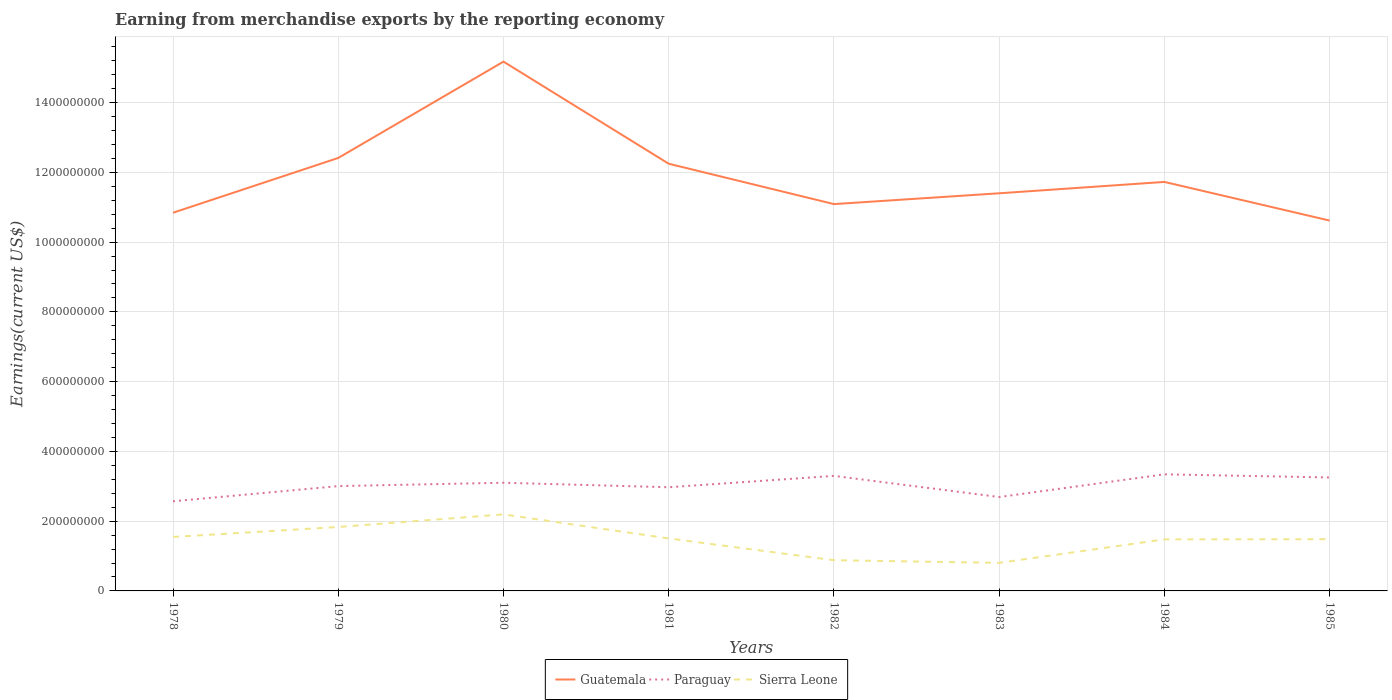How many different coloured lines are there?
Make the answer very short. 3. Across all years, what is the maximum amount earned from merchandise exports in Paraguay?
Provide a short and direct response. 2.57e+08. In which year was the amount earned from merchandise exports in Paraguay maximum?
Provide a succinct answer. 1978. What is the total amount earned from merchandise exports in Guatemala in the graph?
Give a very brief answer. -3.10e+07. What is the difference between the highest and the second highest amount earned from merchandise exports in Sierra Leone?
Your response must be concise. 1.39e+08. What is the difference between the highest and the lowest amount earned from merchandise exports in Paraguay?
Your response must be concise. 4. Is the amount earned from merchandise exports in Guatemala strictly greater than the amount earned from merchandise exports in Sierra Leone over the years?
Your answer should be very brief. No. What is the difference between two consecutive major ticks on the Y-axis?
Give a very brief answer. 2.00e+08. Are the values on the major ticks of Y-axis written in scientific E-notation?
Offer a very short reply. No. Does the graph contain any zero values?
Your answer should be compact. No. Does the graph contain grids?
Offer a terse response. Yes. Where does the legend appear in the graph?
Your answer should be very brief. Bottom center. How many legend labels are there?
Make the answer very short. 3. How are the legend labels stacked?
Your answer should be very brief. Horizontal. What is the title of the graph?
Your answer should be compact. Earning from merchandise exports by the reporting economy. Does "United Kingdom" appear as one of the legend labels in the graph?
Your answer should be compact. No. What is the label or title of the Y-axis?
Your answer should be compact. Earnings(current US$). What is the Earnings(current US$) in Guatemala in 1978?
Provide a succinct answer. 1.08e+09. What is the Earnings(current US$) of Paraguay in 1978?
Offer a terse response. 2.57e+08. What is the Earnings(current US$) in Sierra Leone in 1978?
Make the answer very short. 1.55e+08. What is the Earnings(current US$) of Guatemala in 1979?
Provide a succinct answer. 1.24e+09. What is the Earnings(current US$) in Paraguay in 1979?
Keep it short and to the point. 3.00e+08. What is the Earnings(current US$) in Sierra Leone in 1979?
Offer a terse response. 1.83e+08. What is the Earnings(current US$) in Guatemala in 1980?
Give a very brief answer. 1.52e+09. What is the Earnings(current US$) in Paraguay in 1980?
Offer a terse response. 3.10e+08. What is the Earnings(current US$) in Sierra Leone in 1980?
Your answer should be very brief. 2.19e+08. What is the Earnings(current US$) in Guatemala in 1981?
Give a very brief answer. 1.22e+09. What is the Earnings(current US$) of Paraguay in 1981?
Give a very brief answer. 2.97e+08. What is the Earnings(current US$) in Sierra Leone in 1981?
Offer a terse response. 1.50e+08. What is the Earnings(current US$) of Guatemala in 1982?
Offer a very short reply. 1.11e+09. What is the Earnings(current US$) in Paraguay in 1982?
Ensure brevity in your answer.  3.30e+08. What is the Earnings(current US$) of Sierra Leone in 1982?
Offer a very short reply. 8.81e+07. What is the Earnings(current US$) of Guatemala in 1983?
Ensure brevity in your answer.  1.14e+09. What is the Earnings(current US$) in Paraguay in 1983?
Provide a short and direct response. 2.69e+08. What is the Earnings(current US$) of Sierra Leone in 1983?
Your answer should be very brief. 8.05e+07. What is the Earnings(current US$) in Guatemala in 1984?
Make the answer very short. 1.17e+09. What is the Earnings(current US$) in Paraguay in 1984?
Provide a succinct answer. 3.34e+08. What is the Earnings(current US$) of Sierra Leone in 1984?
Your response must be concise. 1.48e+08. What is the Earnings(current US$) in Guatemala in 1985?
Provide a short and direct response. 1.06e+09. What is the Earnings(current US$) in Paraguay in 1985?
Provide a succinct answer. 3.25e+08. What is the Earnings(current US$) of Sierra Leone in 1985?
Provide a succinct answer. 1.48e+08. Across all years, what is the maximum Earnings(current US$) of Guatemala?
Ensure brevity in your answer.  1.52e+09. Across all years, what is the maximum Earnings(current US$) of Paraguay?
Offer a terse response. 3.34e+08. Across all years, what is the maximum Earnings(current US$) in Sierra Leone?
Make the answer very short. 2.19e+08. Across all years, what is the minimum Earnings(current US$) of Guatemala?
Give a very brief answer. 1.06e+09. Across all years, what is the minimum Earnings(current US$) in Paraguay?
Your response must be concise. 2.57e+08. Across all years, what is the minimum Earnings(current US$) in Sierra Leone?
Give a very brief answer. 8.05e+07. What is the total Earnings(current US$) of Guatemala in the graph?
Keep it short and to the point. 9.55e+09. What is the total Earnings(current US$) of Paraguay in the graph?
Ensure brevity in your answer.  2.42e+09. What is the total Earnings(current US$) in Sierra Leone in the graph?
Keep it short and to the point. 1.17e+09. What is the difference between the Earnings(current US$) of Guatemala in 1978 and that in 1979?
Give a very brief answer. -1.57e+08. What is the difference between the Earnings(current US$) in Paraguay in 1978 and that in 1979?
Keep it short and to the point. -4.35e+07. What is the difference between the Earnings(current US$) in Sierra Leone in 1978 and that in 1979?
Ensure brevity in your answer.  -2.86e+07. What is the difference between the Earnings(current US$) of Guatemala in 1978 and that in 1980?
Offer a terse response. -4.33e+08. What is the difference between the Earnings(current US$) of Paraguay in 1978 and that in 1980?
Give a very brief answer. -5.31e+07. What is the difference between the Earnings(current US$) in Sierra Leone in 1978 and that in 1980?
Provide a short and direct response. -6.47e+07. What is the difference between the Earnings(current US$) in Guatemala in 1978 and that in 1981?
Your answer should be very brief. -1.40e+08. What is the difference between the Earnings(current US$) of Paraguay in 1978 and that in 1981?
Keep it short and to the point. -4.02e+07. What is the difference between the Earnings(current US$) of Sierra Leone in 1978 and that in 1981?
Provide a short and direct response. 4.26e+06. What is the difference between the Earnings(current US$) in Guatemala in 1978 and that in 1982?
Offer a very short reply. -2.48e+07. What is the difference between the Earnings(current US$) of Paraguay in 1978 and that in 1982?
Make the answer very short. -7.28e+07. What is the difference between the Earnings(current US$) of Sierra Leone in 1978 and that in 1982?
Keep it short and to the point. 6.67e+07. What is the difference between the Earnings(current US$) of Guatemala in 1978 and that in 1983?
Provide a succinct answer. -5.58e+07. What is the difference between the Earnings(current US$) in Paraguay in 1978 and that in 1983?
Offer a terse response. -1.22e+07. What is the difference between the Earnings(current US$) in Sierra Leone in 1978 and that in 1983?
Provide a succinct answer. 7.43e+07. What is the difference between the Earnings(current US$) in Guatemala in 1978 and that in 1984?
Provide a succinct answer. -8.84e+07. What is the difference between the Earnings(current US$) of Paraguay in 1978 and that in 1984?
Ensure brevity in your answer.  -7.72e+07. What is the difference between the Earnings(current US$) in Sierra Leone in 1978 and that in 1984?
Make the answer very short. 6.94e+06. What is the difference between the Earnings(current US$) of Guatemala in 1978 and that in 1985?
Offer a terse response. 2.25e+07. What is the difference between the Earnings(current US$) in Paraguay in 1978 and that in 1985?
Your answer should be compact. -6.82e+07. What is the difference between the Earnings(current US$) of Sierra Leone in 1978 and that in 1985?
Your answer should be compact. 6.46e+06. What is the difference between the Earnings(current US$) in Guatemala in 1979 and that in 1980?
Ensure brevity in your answer.  -2.76e+08. What is the difference between the Earnings(current US$) of Paraguay in 1979 and that in 1980?
Offer a very short reply. -9.67e+06. What is the difference between the Earnings(current US$) of Sierra Leone in 1979 and that in 1980?
Offer a terse response. -3.61e+07. What is the difference between the Earnings(current US$) in Guatemala in 1979 and that in 1981?
Provide a succinct answer. 1.66e+07. What is the difference between the Earnings(current US$) of Paraguay in 1979 and that in 1981?
Keep it short and to the point. 3.25e+06. What is the difference between the Earnings(current US$) of Sierra Leone in 1979 and that in 1981?
Provide a succinct answer. 3.28e+07. What is the difference between the Earnings(current US$) of Guatemala in 1979 and that in 1982?
Your answer should be compact. 1.32e+08. What is the difference between the Earnings(current US$) of Paraguay in 1979 and that in 1982?
Offer a terse response. -2.93e+07. What is the difference between the Earnings(current US$) in Sierra Leone in 1979 and that in 1982?
Your answer should be very brief. 9.53e+07. What is the difference between the Earnings(current US$) in Guatemala in 1979 and that in 1983?
Offer a very short reply. 1.01e+08. What is the difference between the Earnings(current US$) of Paraguay in 1979 and that in 1983?
Provide a succinct answer. 3.13e+07. What is the difference between the Earnings(current US$) of Sierra Leone in 1979 and that in 1983?
Provide a succinct answer. 1.03e+08. What is the difference between the Earnings(current US$) of Guatemala in 1979 and that in 1984?
Offer a terse response. 6.87e+07. What is the difference between the Earnings(current US$) of Paraguay in 1979 and that in 1984?
Ensure brevity in your answer.  -3.38e+07. What is the difference between the Earnings(current US$) of Sierra Leone in 1979 and that in 1984?
Keep it short and to the point. 3.55e+07. What is the difference between the Earnings(current US$) of Guatemala in 1979 and that in 1985?
Offer a terse response. 1.80e+08. What is the difference between the Earnings(current US$) in Paraguay in 1979 and that in 1985?
Provide a short and direct response. -2.48e+07. What is the difference between the Earnings(current US$) of Sierra Leone in 1979 and that in 1985?
Keep it short and to the point. 3.50e+07. What is the difference between the Earnings(current US$) of Guatemala in 1980 and that in 1981?
Provide a short and direct response. 2.93e+08. What is the difference between the Earnings(current US$) of Paraguay in 1980 and that in 1981?
Make the answer very short. 1.29e+07. What is the difference between the Earnings(current US$) in Sierra Leone in 1980 and that in 1981?
Your answer should be very brief. 6.90e+07. What is the difference between the Earnings(current US$) in Guatemala in 1980 and that in 1982?
Give a very brief answer. 4.08e+08. What is the difference between the Earnings(current US$) in Paraguay in 1980 and that in 1982?
Provide a short and direct response. -1.97e+07. What is the difference between the Earnings(current US$) of Sierra Leone in 1980 and that in 1982?
Your response must be concise. 1.31e+08. What is the difference between the Earnings(current US$) in Guatemala in 1980 and that in 1983?
Give a very brief answer. 3.77e+08. What is the difference between the Earnings(current US$) in Paraguay in 1980 and that in 1983?
Ensure brevity in your answer.  4.10e+07. What is the difference between the Earnings(current US$) of Sierra Leone in 1980 and that in 1983?
Your response must be concise. 1.39e+08. What is the difference between the Earnings(current US$) of Guatemala in 1980 and that in 1984?
Make the answer very short. 3.45e+08. What is the difference between the Earnings(current US$) in Paraguay in 1980 and that in 1984?
Provide a succinct answer. -2.41e+07. What is the difference between the Earnings(current US$) of Sierra Leone in 1980 and that in 1984?
Keep it short and to the point. 7.17e+07. What is the difference between the Earnings(current US$) in Guatemala in 1980 and that in 1985?
Your response must be concise. 4.56e+08. What is the difference between the Earnings(current US$) in Paraguay in 1980 and that in 1985?
Ensure brevity in your answer.  -1.51e+07. What is the difference between the Earnings(current US$) of Sierra Leone in 1980 and that in 1985?
Keep it short and to the point. 7.12e+07. What is the difference between the Earnings(current US$) of Guatemala in 1981 and that in 1982?
Offer a terse response. 1.16e+08. What is the difference between the Earnings(current US$) in Paraguay in 1981 and that in 1982?
Provide a short and direct response. -3.26e+07. What is the difference between the Earnings(current US$) of Sierra Leone in 1981 and that in 1982?
Provide a short and direct response. 6.24e+07. What is the difference between the Earnings(current US$) of Guatemala in 1981 and that in 1983?
Give a very brief answer. 8.47e+07. What is the difference between the Earnings(current US$) of Paraguay in 1981 and that in 1983?
Your response must be concise. 2.80e+07. What is the difference between the Earnings(current US$) in Sierra Leone in 1981 and that in 1983?
Your response must be concise. 7.00e+07. What is the difference between the Earnings(current US$) of Guatemala in 1981 and that in 1984?
Your answer should be compact. 5.21e+07. What is the difference between the Earnings(current US$) in Paraguay in 1981 and that in 1984?
Offer a terse response. -3.70e+07. What is the difference between the Earnings(current US$) of Sierra Leone in 1981 and that in 1984?
Provide a succinct answer. 2.68e+06. What is the difference between the Earnings(current US$) in Guatemala in 1981 and that in 1985?
Provide a short and direct response. 1.63e+08. What is the difference between the Earnings(current US$) of Paraguay in 1981 and that in 1985?
Your response must be concise. -2.80e+07. What is the difference between the Earnings(current US$) in Sierra Leone in 1981 and that in 1985?
Make the answer very short. 2.20e+06. What is the difference between the Earnings(current US$) of Guatemala in 1982 and that in 1983?
Your answer should be very brief. -3.10e+07. What is the difference between the Earnings(current US$) of Paraguay in 1982 and that in 1983?
Offer a very short reply. 6.06e+07. What is the difference between the Earnings(current US$) in Sierra Leone in 1982 and that in 1983?
Your answer should be compact. 7.59e+06. What is the difference between the Earnings(current US$) of Guatemala in 1982 and that in 1984?
Provide a short and direct response. -6.36e+07. What is the difference between the Earnings(current US$) in Paraguay in 1982 and that in 1984?
Provide a succinct answer. -4.46e+06. What is the difference between the Earnings(current US$) in Sierra Leone in 1982 and that in 1984?
Your response must be concise. -5.97e+07. What is the difference between the Earnings(current US$) of Guatemala in 1982 and that in 1985?
Keep it short and to the point. 4.73e+07. What is the difference between the Earnings(current US$) of Paraguay in 1982 and that in 1985?
Ensure brevity in your answer.  4.56e+06. What is the difference between the Earnings(current US$) of Sierra Leone in 1982 and that in 1985?
Make the answer very short. -6.02e+07. What is the difference between the Earnings(current US$) of Guatemala in 1983 and that in 1984?
Your answer should be compact. -3.26e+07. What is the difference between the Earnings(current US$) in Paraguay in 1983 and that in 1984?
Offer a terse response. -6.51e+07. What is the difference between the Earnings(current US$) in Sierra Leone in 1983 and that in 1984?
Give a very brief answer. -6.73e+07. What is the difference between the Earnings(current US$) in Guatemala in 1983 and that in 1985?
Your response must be concise. 7.83e+07. What is the difference between the Earnings(current US$) of Paraguay in 1983 and that in 1985?
Your answer should be very brief. -5.61e+07. What is the difference between the Earnings(current US$) of Sierra Leone in 1983 and that in 1985?
Keep it short and to the point. -6.78e+07. What is the difference between the Earnings(current US$) in Guatemala in 1984 and that in 1985?
Keep it short and to the point. 1.11e+08. What is the difference between the Earnings(current US$) of Paraguay in 1984 and that in 1985?
Your answer should be compact. 9.01e+06. What is the difference between the Earnings(current US$) of Sierra Leone in 1984 and that in 1985?
Your answer should be very brief. -4.81e+05. What is the difference between the Earnings(current US$) of Guatemala in 1978 and the Earnings(current US$) of Paraguay in 1979?
Your response must be concise. 7.84e+08. What is the difference between the Earnings(current US$) in Guatemala in 1978 and the Earnings(current US$) in Sierra Leone in 1979?
Your response must be concise. 9.01e+08. What is the difference between the Earnings(current US$) in Paraguay in 1978 and the Earnings(current US$) in Sierra Leone in 1979?
Make the answer very short. 7.37e+07. What is the difference between the Earnings(current US$) of Guatemala in 1978 and the Earnings(current US$) of Paraguay in 1980?
Keep it short and to the point. 7.74e+08. What is the difference between the Earnings(current US$) of Guatemala in 1978 and the Earnings(current US$) of Sierra Leone in 1980?
Provide a short and direct response. 8.65e+08. What is the difference between the Earnings(current US$) of Paraguay in 1978 and the Earnings(current US$) of Sierra Leone in 1980?
Provide a succinct answer. 3.76e+07. What is the difference between the Earnings(current US$) in Guatemala in 1978 and the Earnings(current US$) in Paraguay in 1981?
Offer a very short reply. 7.87e+08. What is the difference between the Earnings(current US$) of Guatemala in 1978 and the Earnings(current US$) of Sierra Leone in 1981?
Ensure brevity in your answer.  9.34e+08. What is the difference between the Earnings(current US$) in Paraguay in 1978 and the Earnings(current US$) in Sierra Leone in 1981?
Provide a short and direct response. 1.07e+08. What is the difference between the Earnings(current US$) of Guatemala in 1978 and the Earnings(current US$) of Paraguay in 1982?
Your answer should be compact. 7.54e+08. What is the difference between the Earnings(current US$) in Guatemala in 1978 and the Earnings(current US$) in Sierra Leone in 1982?
Keep it short and to the point. 9.96e+08. What is the difference between the Earnings(current US$) of Paraguay in 1978 and the Earnings(current US$) of Sierra Leone in 1982?
Give a very brief answer. 1.69e+08. What is the difference between the Earnings(current US$) of Guatemala in 1978 and the Earnings(current US$) of Paraguay in 1983?
Provide a succinct answer. 8.15e+08. What is the difference between the Earnings(current US$) of Guatemala in 1978 and the Earnings(current US$) of Sierra Leone in 1983?
Provide a short and direct response. 1.00e+09. What is the difference between the Earnings(current US$) of Paraguay in 1978 and the Earnings(current US$) of Sierra Leone in 1983?
Keep it short and to the point. 1.77e+08. What is the difference between the Earnings(current US$) of Guatemala in 1978 and the Earnings(current US$) of Paraguay in 1984?
Provide a succinct answer. 7.50e+08. What is the difference between the Earnings(current US$) in Guatemala in 1978 and the Earnings(current US$) in Sierra Leone in 1984?
Give a very brief answer. 9.36e+08. What is the difference between the Earnings(current US$) in Paraguay in 1978 and the Earnings(current US$) in Sierra Leone in 1984?
Provide a succinct answer. 1.09e+08. What is the difference between the Earnings(current US$) of Guatemala in 1978 and the Earnings(current US$) of Paraguay in 1985?
Your answer should be compact. 7.59e+08. What is the difference between the Earnings(current US$) in Guatemala in 1978 and the Earnings(current US$) in Sierra Leone in 1985?
Offer a very short reply. 9.36e+08. What is the difference between the Earnings(current US$) in Paraguay in 1978 and the Earnings(current US$) in Sierra Leone in 1985?
Your answer should be very brief. 1.09e+08. What is the difference between the Earnings(current US$) of Guatemala in 1979 and the Earnings(current US$) of Paraguay in 1980?
Keep it short and to the point. 9.31e+08. What is the difference between the Earnings(current US$) in Guatemala in 1979 and the Earnings(current US$) in Sierra Leone in 1980?
Make the answer very short. 1.02e+09. What is the difference between the Earnings(current US$) of Paraguay in 1979 and the Earnings(current US$) of Sierra Leone in 1980?
Your answer should be compact. 8.10e+07. What is the difference between the Earnings(current US$) of Guatemala in 1979 and the Earnings(current US$) of Paraguay in 1981?
Offer a very short reply. 9.44e+08. What is the difference between the Earnings(current US$) of Guatemala in 1979 and the Earnings(current US$) of Sierra Leone in 1981?
Provide a short and direct response. 1.09e+09. What is the difference between the Earnings(current US$) in Paraguay in 1979 and the Earnings(current US$) in Sierra Leone in 1981?
Your answer should be compact. 1.50e+08. What is the difference between the Earnings(current US$) in Guatemala in 1979 and the Earnings(current US$) in Paraguay in 1982?
Offer a very short reply. 9.12e+08. What is the difference between the Earnings(current US$) of Guatemala in 1979 and the Earnings(current US$) of Sierra Leone in 1982?
Your answer should be very brief. 1.15e+09. What is the difference between the Earnings(current US$) of Paraguay in 1979 and the Earnings(current US$) of Sierra Leone in 1982?
Offer a very short reply. 2.12e+08. What is the difference between the Earnings(current US$) in Guatemala in 1979 and the Earnings(current US$) in Paraguay in 1983?
Keep it short and to the point. 9.72e+08. What is the difference between the Earnings(current US$) in Guatemala in 1979 and the Earnings(current US$) in Sierra Leone in 1983?
Keep it short and to the point. 1.16e+09. What is the difference between the Earnings(current US$) in Paraguay in 1979 and the Earnings(current US$) in Sierra Leone in 1983?
Offer a terse response. 2.20e+08. What is the difference between the Earnings(current US$) in Guatemala in 1979 and the Earnings(current US$) in Paraguay in 1984?
Offer a terse response. 9.07e+08. What is the difference between the Earnings(current US$) of Guatemala in 1979 and the Earnings(current US$) of Sierra Leone in 1984?
Offer a very short reply. 1.09e+09. What is the difference between the Earnings(current US$) of Paraguay in 1979 and the Earnings(current US$) of Sierra Leone in 1984?
Give a very brief answer. 1.53e+08. What is the difference between the Earnings(current US$) in Guatemala in 1979 and the Earnings(current US$) in Paraguay in 1985?
Provide a short and direct response. 9.16e+08. What is the difference between the Earnings(current US$) of Guatemala in 1979 and the Earnings(current US$) of Sierra Leone in 1985?
Your response must be concise. 1.09e+09. What is the difference between the Earnings(current US$) in Paraguay in 1979 and the Earnings(current US$) in Sierra Leone in 1985?
Provide a succinct answer. 1.52e+08. What is the difference between the Earnings(current US$) of Guatemala in 1980 and the Earnings(current US$) of Paraguay in 1981?
Your answer should be compact. 1.22e+09. What is the difference between the Earnings(current US$) in Guatemala in 1980 and the Earnings(current US$) in Sierra Leone in 1981?
Make the answer very short. 1.37e+09. What is the difference between the Earnings(current US$) of Paraguay in 1980 and the Earnings(current US$) of Sierra Leone in 1981?
Offer a terse response. 1.60e+08. What is the difference between the Earnings(current US$) in Guatemala in 1980 and the Earnings(current US$) in Paraguay in 1982?
Offer a very short reply. 1.19e+09. What is the difference between the Earnings(current US$) of Guatemala in 1980 and the Earnings(current US$) of Sierra Leone in 1982?
Provide a succinct answer. 1.43e+09. What is the difference between the Earnings(current US$) of Paraguay in 1980 and the Earnings(current US$) of Sierra Leone in 1982?
Offer a terse response. 2.22e+08. What is the difference between the Earnings(current US$) of Guatemala in 1980 and the Earnings(current US$) of Paraguay in 1983?
Your response must be concise. 1.25e+09. What is the difference between the Earnings(current US$) of Guatemala in 1980 and the Earnings(current US$) of Sierra Leone in 1983?
Keep it short and to the point. 1.44e+09. What is the difference between the Earnings(current US$) in Paraguay in 1980 and the Earnings(current US$) in Sierra Leone in 1983?
Your answer should be very brief. 2.30e+08. What is the difference between the Earnings(current US$) of Guatemala in 1980 and the Earnings(current US$) of Paraguay in 1984?
Your answer should be very brief. 1.18e+09. What is the difference between the Earnings(current US$) in Guatemala in 1980 and the Earnings(current US$) in Sierra Leone in 1984?
Provide a succinct answer. 1.37e+09. What is the difference between the Earnings(current US$) in Paraguay in 1980 and the Earnings(current US$) in Sierra Leone in 1984?
Give a very brief answer. 1.62e+08. What is the difference between the Earnings(current US$) in Guatemala in 1980 and the Earnings(current US$) in Paraguay in 1985?
Provide a succinct answer. 1.19e+09. What is the difference between the Earnings(current US$) in Guatemala in 1980 and the Earnings(current US$) in Sierra Leone in 1985?
Give a very brief answer. 1.37e+09. What is the difference between the Earnings(current US$) in Paraguay in 1980 and the Earnings(current US$) in Sierra Leone in 1985?
Give a very brief answer. 1.62e+08. What is the difference between the Earnings(current US$) in Guatemala in 1981 and the Earnings(current US$) in Paraguay in 1982?
Provide a short and direct response. 8.95e+08. What is the difference between the Earnings(current US$) of Guatemala in 1981 and the Earnings(current US$) of Sierra Leone in 1982?
Keep it short and to the point. 1.14e+09. What is the difference between the Earnings(current US$) in Paraguay in 1981 and the Earnings(current US$) in Sierra Leone in 1982?
Your answer should be compact. 2.09e+08. What is the difference between the Earnings(current US$) of Guatemala in 1981 and the Earnings(current US$) of Paraguay in 1983?
Offer a terse response. 9.56e+08. What is the difference between the Earnings(current US$) in Guatemala in 1981 and the Earnings(current US$) in Sierra Leone in 1983?
Give a very brief answer. 1.14e+09. What is the difference between the Earnings(current US$) in Paraguay in 1981 and the Earnings(current US$) in Sierra Leone in 1983?
Your answer should be very brief. 2.17e+08. What is the difference between the Earnings(current US$) of Guatemala in 1981 and the Earnings(current US$) of Paraguay in 1984?
Give a very brief answer. 8.90e+08. What is the difference between the Earnings(current US$) of Guatemala in 1981 and the Earnings(current US$) of Sierra Leone in 1984?
Your answer should be very brief. 1.08e+09. What is the difference between the Earnings(current US$) of Paraguay in 1981 and the Earnings(current US$) of Sierra Leone in 1984?
Your answer should be very brief. 1.49e+08. What is the difference between the Earnings(current US$) of Guatemala in 1981 and the Earnings(current US$) of Paraguay in 1985?
Offer a terse response. 8.99e+08. What is the difference between the Earnings(current US$) in Guatemala in 1981 and the Earnings(current US$) in Sierra Leone in 1985?
Ensure brevity in your answer.  1.08e+09. What is the difference between the Earnings(current US$) of Paraguay in 1981 and the Earnings(current US$) of Sierra Leone in 1985?
Your answer should be very brief. 1.49e+08. What is the difference between the Earnings(current US$) of Guatemala in 1982 and the Earnings(current US$) of Paraguay in 1983?
Your response must be concise. 8.40e+08. What is the difference between the Earnings(current US$) in Guatemala in 1982 and the Earnings(current US$) in Sierra Leone in 1983?
Keep it short and to the point. 1.03e+09. What is the difference between the Earnings(current US$) in Paraguay in 1982 and the Earnings(current US$) in Sierra Leone in 1983?
Provide a succinct answer. 2.49e+08. What is the difference between the Earnings(current US$) of Guatemala in 1982 and the Earnings(current US$) of Paraguay in 1984?
Provide a succinct answer. 7.75e+08. What is the difference between the Earnings(current US$) in Guatemala in 1982 and the Earnings(current US$) in Sierra Leone in 1984?
Provide a short and direct response. 9.61e+08. What is the difference between the Earnings(current US$) in Paraguay in 1982 and the Earnings(current US$) in Sierra Leone in 1984?
Your response must be concise. 1.82e+08. What is the difference between the Earnings(current US$) of Guatemala in 1982 and the Earnings(current US$) of Paraguay in 1985?
Keep it short and to the point. 7.84e+08. What is the difference between the Earnings(current US$) of Guatemala in 1982 and the Earnings(current US$) of Sierra Leone in 1985?
Your response must be concise. 9.61e+08. What is the difference between the Earnings(current US$) of Paraguay in 1982 and the Earnings(current US$) of Sierra Leone in 1985?
Keep it short and to the point. 1.82e+08. What is the difference between the Earnings(current US$) in Guatemala in 1983 and the Earnings(current US$) in Paraguay in 1984?
Provide a short and direct response. 8.06e+08. What is the difference between the Earnings(current US$) in Guatemala in 1983 and the Earnings(current US$) in Sierra Leone in 1984?
Offer a very short reply. 9.92e+08. What is the difference between the Earnings(current US$) in Paraguay in 1983 and the Earnings(current US$) in Sierra Leone in 1984?
Offer a very short reply. 1.21e+08. What is the difference between the Earnings(current US$) of Guatemala in 1983 and the Earnings(current US$) of Paraguay in 1985?
Offer a very short reply. 8.15e+08. What is the difference between the Earnings(current US$) in Guatemala in 1983 and the Earnings(current US$) in Sierra Leone in 1985?
Keep it short and to the point. 9.92e+08. What is the difference between the Earnings(current US$) of Paraguay in 1983 and the Earnings(current US$) of Sierra Leone in 1985?
Offer a very short reply. 1.21e+08. What is the difference between the Earnings(current US$) in Guatemala in 1984 and the Earnings(current US$) in Paraguay in 1985?
Your response must be concise. 8.47e+08. What is the difference between the Earnings(current US$) in Guatemala in 1984 and the Earnings(current US$) in Sierra Leone in 1985?
Your answer should be compact. 1.02e+09. What is the difference between the Earnings(current US$) of Paraguay in 1984 and the Earnings(current US$) of Sierra Leone in 1985?
Give a very brief answer. 1.86e+08. What is the average Earnings(current US$) in Guatemala per year?
Offer a terse response. 1.19e+09. What is the average Earnings(current US$) in Paraguay per year?
Your answer should be very brief. 3.03e+08. What is the average Earnings(current US$) in Sierra Leone per year?
Your answer should be very brief. 1.47e+08. In the year 1978, what is the difference between the Earnings(current US$) in Guatemala and Earnings(current US$) in Paraguay?
Your response must be concise. 8.27e+08. In the year 1978, what is the difference between the Earnings(current US$) in Guatemala and Earnings(current US$) in Sierra Leone?
Keep it short and to the point. 9.29e+08. In the year 1978, what is the difference between the Earnings(current US$) in Paraguay and Earnings(current US$) in Sierra Leone?
Keep it short and to the point. 1.02e+08. In the year 1979, what is the difference between the Earnings(current US$) in Guatemala and Earnings(current US$) in Paraguay?
Offer a terse response. 9.41e+08. In the year 1979, what is the difference between the Earnings(current US$) in Guatemala and Earnings(current US$) in Sierra Leone?
Provide a short and direct response. 1.06e+09. In the year 1979, what is the difference between the Earnings(current US$) of Paraguay and Earnings(current US$) of Sierra Leone?
Make the answer very short. 1.17e+08. In the year 1980, what is the difference between the Earnings(current US$) in Guatemala and Earnings(current US$) in Paraguay?
Keep it short and to the point. 1.21e+09. In the year 1980, what is the difference between the Earnings(current US$) in Guatemala and Earnings(current US$) in Sierra Leone?
Offer a very short reply. 1.30e+09. In the year 1980, what is the difference between the Earnings(current US$) of Paraguay and Earnings(current US$) of Sierra Leone?
Your answer should be very brief. 9.07e+07. In the year 1981, what is the difference between the Earnings(current US$) of Guatemala and Earnings(current US$) of Paraguay?
Your answer should be very brief. 9.27e+08. In the year 1981, what is the difference between the Earnings(current US$) in Guatemala and Earnings(current US$) in Sierra Leone?
Provide a short and direct response. 1.07e+09. In the year 1981, what is the difference between the Earnings(current US$) in Paraguay and Earnings(current US$) in Sierra Leone?
Offer a very short reply. 1.47e+08. In the year 1982, what is the difference between the Earnings(current US$) in Guatemala and Earnings(current US$) in Paraguay?
Your answer should be very brief. 7.79e+08. In the year 1982, what is the difference between the Earnings(current US$) in Guatemala and Earnings(current US$) in Sierra Leone?
Your response must be concise. 1.02e+09. In the year 1982, what is the difference between the Earnings(current US$) of Paraguay and Earnings(current US$) of Sierra Leone?
Provide a short and direct response. 2.42e+08. In the year 1983, what is the difference between the Earnings(current US$) of Guatemala and Earnings(current US$) of Paraguay?
Your response must be concise. 8.71e+08. In the year 1983, what is the difference between the Earnings(current US$) of Guatemala and Earnings(current US$) of Sierra Leone?
Keep it short and to the point. 1.06e+09. In the year 1983, what is the difference between the Earnings(current US$) of Paraguay and Earnings(current US$) of Sierra Leone?
Provide a succinct answer. 1.89e+08. In the year 1984, what is the difference between the Earnings(current US$) of Guatemala and Earnings(current US$) of Paraguay?
Keep it short and to the point. 8.38e+08. In the year 1984, what is the difference between the Earnings(current US$) in Guatemala and Earnings(current US$) in Sierra Leone?
Make the answer very short. 1.02e+09. In the year 1984, what is the difference between the Earnings(current US$) of Paraguay and Earnings(current US$) of Sierra Leone?
Make the answer very short. 1.86e+08. In the year 1985, what is the difference between the Earnings(current US$) of Guatemala and Earnings(current US$) of Paraguay?
Your answer should be compact. 7.36e+08. In the year 1985, what is the difference between the Earnings(current US$) of Guatemala and Earnings(current US$) of Sierra Leone?
Give a very brief answer. 9.13e+08. In the year 1985, what is the difference between the Earnings(current US$) in Paraguay and Earnings(current US$) in Sierra Leone?
Provide a succinct answer. 1.77e+08. What is the ratio of the Earnings(current US$) in Guatemala in 1978 to that in 1979?
Your answer should be very brief. 0.87. What is the ratio of the Earnings(current US$) of Paraguay in 1978 to that in 1979?
Make the answer very short. 0.86. What is the ratio of the Earnings(current US$) in Sierra Leone in 1978 to that in 1979?
Ensure brevity in your answer.  0.84. What is the ratio of the Earnings(current US$) of Guatemala in 1978 to that in 1980?
Offer a terse response. 0.71. What is the ratio of the Earnings(current US$) of Paraguay in 1978 to that in 1980?
Your response must be concise. 0.83. What is the ratio of the Earnings(current US$) in Sierra Leone in 1978 to that in 1980?
Make the answer very short. 0.71. What is the ratio of the Earnings(current US$) in Guatemala in 1978 to that in 1981?
Your response must be concise. 0.89. What is the ratio of the Earnings(current US$) in Paraguay in 1978 to that in 1981?
Your response must be concise. 0.86. What is the ratio of the Earnings(current US$) of Sierra Leone in 1978 to that in 1981?
Provide a succinct answer. 1.03. What is the ratio of the Earnings(current US$) of Guatemala in 1978 to that in 1982?
Offer a very short reply. 0.98. What is the ratio of the Earnings(current US$) of Paraguay in 1978 to that in 1982?
Your answer should be very brief. 0.78. What is the ratio of the Earnings(current US$) in Sierra Leone in 1978 to that in 1982?
Your answer should be compact. 1.76. What is the ratio of the Earnings(current US$) in Guatemala in 1978 to that in 1983?
Your answer should be very brief. 0.95. What is the ratio of the Earnings(current US$) in Paraguay in 1978 to that in 1983?
Your response must be concise. 0.95. What is the ratio of the Earnings(current US$) in Sierra Leone in 1978 to that in 1983?
Keep it short and to the point. 1.92. What is the ratio of the Earnings(current US$) in Guatemala in 1978 to that in 1984?
Keep it short and to the point. 0.92. What is the ratio of the Earnings(current US$) in Paraguay in 1978 to that in 1984?
Provide a succinct answer. 0.77. What is the ratio of the Earnings(current US$) of Sierra Leone in 1978 to that in 1984?
Ensure brevity in your answer.  1.05. What is the ratio of the Earnings(current US$) in Guatemala in 1978 to that in 1985?
Ensure brevity in your answer.  1.02. What is the ratio of the Earnings(current US$) in Paraguay in 1978 to that in 1985?
Make the answer very short. 0.79. What is the ratio of the Earnings(current US$) of Sierra Leone in 1978 to that in 1985?
Offer a very short reply. 1.04. What is the ratio of the Earnings(current US$) of Guatemala in 1979 to that in 1980?
Your answer should be very brief. 0.82. What is the ratio of the Earnings(current US$) of Paraguay in 1979 to that in 1980?
Offer a very short reply. 0.97. What is the ratio of the Earnings(current US$) of Sierra Leone in 1979 to that in 1980?
Ensure brevity in your answer.  0.84. What is the ratio of the Earnings(current US$) in Guatemala in 1979 to that in 1981?
Offer a very short reply. 1.01. What is the ratio of the Earnings(current US$) of Paraguay in 1979 to that in 1981?
Your answer should be compact. 1.01. What is the ratio of the Earnings(current US$) in Sierra Leone in 1979 to that in 1981?
Give a very brief answer. 1.22. What is the ratio of the Earnings(current US$) in Guatemala in 1979 to that in 1982?
Your response must be concise. 1.12. What is the ratio of the Earnings(current US$) in Paraguay in 1979 to that in 1982?
Offer a terse response. 0.91. What is the ratio of the Earnings(current US$) of Sierra Leone in 1979 to that in 1982?
Provide a succinct answer. 2.08. What is the ratio of the Earnings(current US$) of Guatemala in 1979 to that in 1983?
Make the answer very short. 1.09. What is the ratio of the Earnings(current US$) in Paraguay in 1979 to that in 1983?
Ensure brevity in your answer.  1.12. What is the ratio of the Earnings(current US$) in Sierra Leone in 1979 to that in 1983?
Your response must be concise. 2.28. What is the ratio of the Earnings(current US$) in Guatemala in 1979 to that in 1984?
Make the answer very short. 1.06. What is the ratio of the Earnings(current US$) of Paraguay in 1979 to that in 1984?
Offer a terse response. 0.9. What is the ratio of the Earnings(current US$) in Sierra Leone in 1979 to that in 1984?
Give a very brief answer. 1.24. What is the ratio of the Earnings(current US$) in Guatemala in 1979 to that in 1985?
Provide a short and direct response. 1.17. What is the ratio of the Earnings(current US$) in Paraguay in 1979 to that in 1985?
Provide a succinct answer. 0.92. What is the ratio of the Earnings(current US$) of Sierra Leone in 1979 to that in 1985?
Offer a terse response. 1.24. What is the ratio of the Earnings(current US$) in Guatemala in 1980 to that in 1981?
Offer a terse response. 1.24. What is the ratio of the Earnings(current US$) of Paraguay in 1980 to that in 1981?
Ensure brevity in your answer.  1.04. What is the ratio of the Earnings(current US$) in Sierra Leone in 1980 to that in 1981?
Ensure brevity in your answer.  1.46. What is the ratio of the Earnings(current US$) in Guatemala in 1980 to that in 1982?
Keep it short and to the point. 1.37. What is the ratio of the Earnings(current US$) of Paraguay in 1980 to that in 1982?
Make the answer very short. 0.94. What is the ratio of the Earnings(current US$) of Sierra Leone in 1980 to that in 1982?
Ensure brevity in your answer.  2.49. What is the ratio of the Earnings(current US$) in Guatemala in 1980 to that in 1983?
Provide a short and direct response. 1.33. What is the ratio of the Earnings(current US$) in Paraguay in 1980 to that in 1983?
Ensure brevity in your answer.  1.15. What is the ratio of the Earnings(current US$) in Sierra Leone in 1980 to that in 1983?
Ensure brevity in your answer.  2.73. What is the ratio of the Earnings(current US$) in Guatemala in 1980 to that in 1984?
Offer a very short reply. 1.29. What is the ratio of the Earnings(current US$) in Paraguay in 1980 to that in 1984?
Make the answer very short. 0.93. What is the ratio of the Earnings(current US$) in Sierra Leone in 1980 to that in 1984?
Your response must be concise. 1.48. What is the ratio of the Earnings(current US$) of Guatemala in 1980 to that in 1985?
Keep it short and to the point. 1.43. What is the ratio of the Earnings(current US$) of Paraguay in 1980 to that in 1985?
Ensure brevity in your answer.  0.95. What is the ratio of the Earnings(current US$) in Sierra Leone in 1980 to that in 1985?
Your answer should be compact. 1.48. What is the ratio of the Earnings(current US$) of Guatemala in 1981 to that in 1982?
Ensure brevity in your answer.  1.1. What is the ratio of the Earnings(current US$) of Paraguay in 1981 to that in 1982?
Provide a short and direct response. 0.9. What is the ratio of the Earnings(current US$) in Sierra Leone in 1981 to that in 1982?
Offer a very short reply. 1.71. What is the ratio of the Earnings(current US$) in Guatemala in 1981 to that in 1983?
Ensure brevity in your answer.  1.07. What is the ratio of the Earnings(current US$) in Paraguay in 1981 to that in 1983?
Your response must be concise. 1.1. What is the ratio of the Earnings(current US$) of Sierra Leone in 1981 to that in 1983?
Ensure brevity in your answer.  1.87. What is the ratio of the Earnings(current US$) of Guatemala in 1981 to that in 1984?
Offer a terse response. 1.04. What is the ratio of the Earnings(current US$) in Paraguay in 1981 to that in 1984?
Your response must be concise. 0.89. What is the ratio of the Earnings(current US$) of Sierra Leone in 1981 to that in 1984?
Provide a succinct answer. 1.02. What is the ratio of the Earnings(current US$) in Guatemala in 1981 to that in 1985?
Your response must be concise. 1.15. What is the ratio of the Earnings(current US$) of Paraguay in 1981 to that in 1985?
Make the answer very short. 0.91. What is the ratio of the Earnings(current US$) of Sierra Leone in 1981 to that in 1985?
Your answer should be compact. 1.01. What is the ratio of the Earnings(current US$) of Guatemala in 1982 to that in 1983?
Your answer should be very brief. 0.97. What is the ratio of the Earnings(current US$) of Paraguay in 1982 to that in 1983?
Ensure brevity in your answer.  1.23. What is the ratio of the Earnings(current US$) in Sierra Leone in 1982 to that in 1983?
Ensure brevity in your answer.  1.09. What is the ratio of the Earnings(current US$) of Guatemala in 1982 to that in 1984?
Provide a succinct answer. 0.95. What is the ratio of the Earnings(current US$) in Paraguay in 1982 to that in 1984?
Offer a very short reply. 0.99. What is the ratio of the Earnings(current US$) in Sierra Leone in 1982 to that in 1984?
Keep it short and to the point. 0.6. What is the ratio of the Earnings(current US$) of Guatemala in 1982 to that in 1985?
Give a very brief answer. 1.04. What is the ratio of the Earnings(current US$) of Sierra Leone in 1982 to that in 1985?
Make the answer very short. 0.59. What is the ratio of the Earnings(current US$) of Guatemala in 1983 to that in 1984?
Your response must be concise. 0.97. What is the ratio of the Earnings(current US$) of Paraguay in 1983 to that in 1984?
Give a very brief answer. 0.81. What is the ratio of the Earnings(current US$) in Sierra Leone in 1983 to that in 1984?
Provide a succinct answer. 0.54. What is the ratio of the Earnings(current US$) in Guatemala in 1983 to that in 1985?
Your answer should be very brief. 1.07. What is the ratio of the Earnings(current US$) in Paraguay in 1983 to that in 1985?
Give a very brief answer. 0.83. What is the ratio of the Earnings(current US$) in Sierra Leone in 1983 to that in 1985?
Offer a terse response. 0.54. What is the ratio of the Earnings(current US$) in Guatemala in 1984 to that in 1985?
Provide a succinct answer. 1.1. What is the ratio of the Earnings(current US$) in Paraguay in 1984 to that in 1985?
Your answer should be compact. 1.03. What is the difference between the highest and the second highest Earnings(current US$) in Guatemala?
Offer a terse response. 2.76e+08. What is the difference between the highest and the second highest Earnings(current US$) of Paraguay?
Provide a succinct answer. 4.46e+06. What is the difference between the highest and the second highest Earnings(current US$) of Sierra Leone?
Offer a very short reply. 3.61e+07. What is the difference between the highest and the lowest Earnings(current US$) in Guatemala?
Offer a very short reply. 4.56e+08. What is the difference between the highest and the lowest Earnings(current US$) of Paraguay?
Give a very brief answer. 7.72e+07. What is the difference between the highest and the lowest Earnings(current US$) in Sierra Leone?
Offer a terse response. 1.39e+08. 